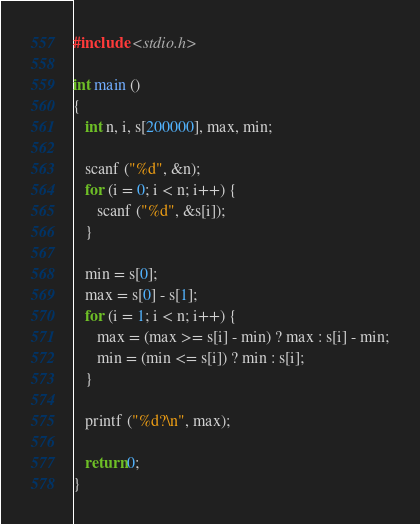<code> <loc_0><loc_0><loc_500><loc_500><_C_>#include <stdio.h>

int main ()
{
   int n, i, s[200000], max, min;

   scanf ("%d", &n);
   for (i = 0; i < n; i++) {
      scanf ("%d", &s[i]);
   }

   min = s[0]; 
   max = s[0] - s[1];
   for (i = 1; i < n; i++) {
      max = (max >= s[i] - min) ? max : s[i] - min;
      min = (min <= s[i]) ? min : s[i];
   }

   printf ("%d?\n", max);

   return 0;
}</code> 